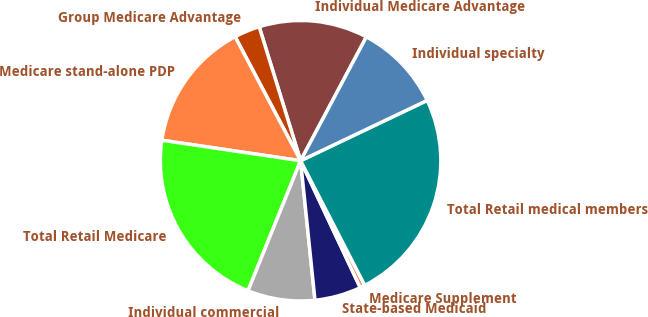Convert chart to OTSL. <chart><loc_0><loc_0><loc_500><loc_500><pie_chart><fcel>Individual Medicare Advantage<fcel>Group Medicare Advantage<fcel>Medicare stand-alone PDP<fcel>Total Retail Medicare<fcel>Individual commercial<fcel>State-based Medicaid<fcel>Medicare Supplement<fcel>Total Retail medical members<fcel>Individual specialty<nl><fcel>12.54%<fcel>2.96%<fcel>14.93%<fcel>21.22%<fcel>7.75%<fcel>5.36%<fcel>0.57%<fcel>24.51%<fcel>10.15%<nl></chart> 